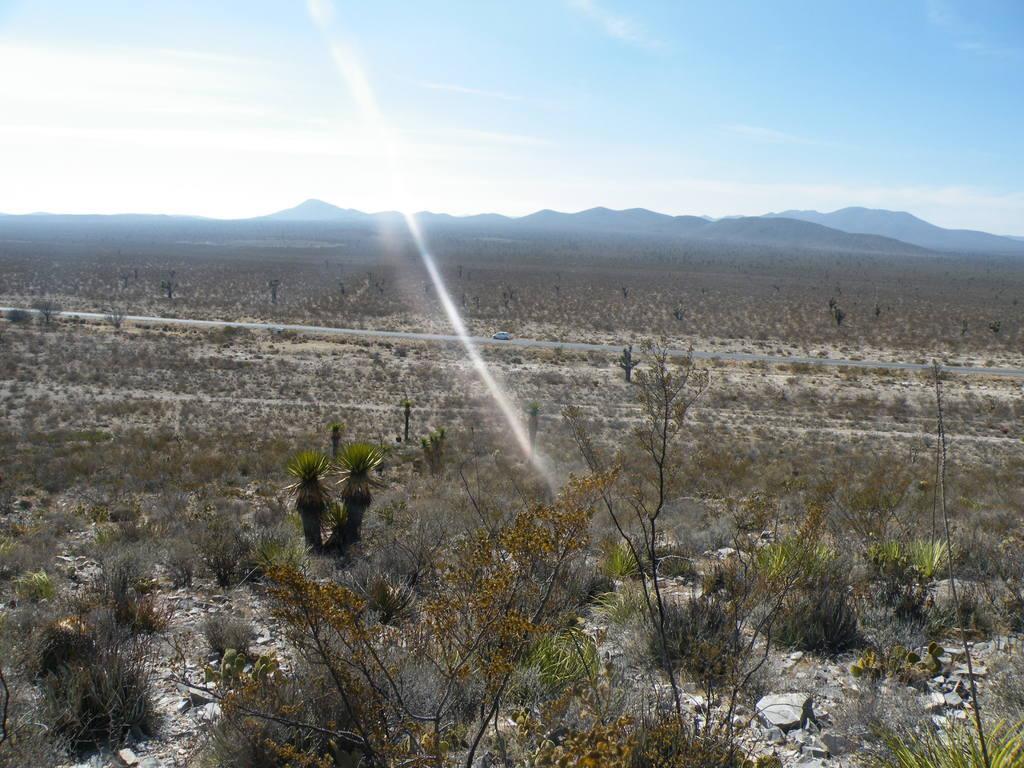Could you give a brief overview of what you see in this image? In this picture I can see planets on the surface in the foreground. I can see a vehicle on the road. I can see hills in the background. I can see clouds in the sky. 